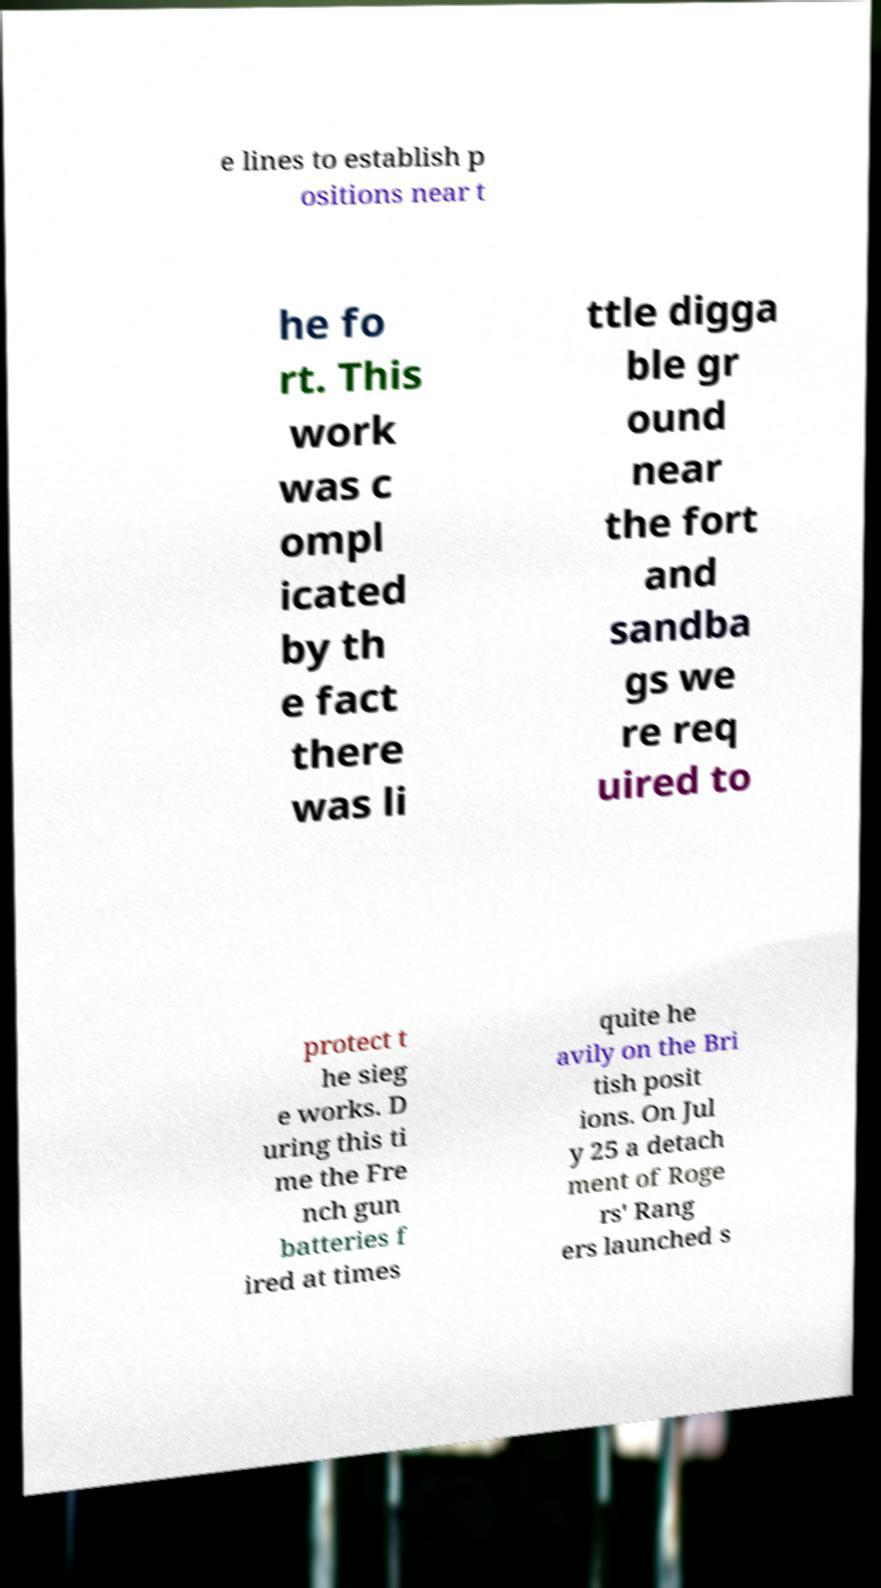Could you extract and type out the text from this image? e lines to establish p ositions near t he fo rt. This work was c ompl icated by th e fact there was li ttle digga ble gr ound near the fort and sandba gs we re req uired to protect t he sieg e works. D uring this ti me the Fre nch gun batteries f ired at times quite he avily on the Bri tish posit ions. On Jul y 25 a detach ment of Roge rs' Rang ers launched s 